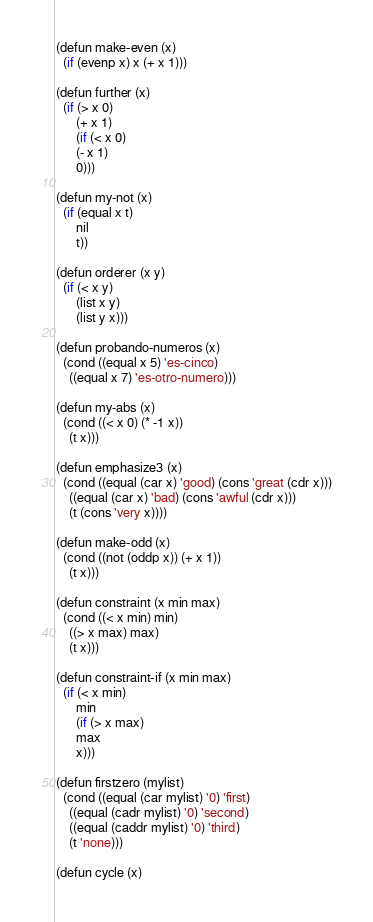Convert code to text. <code><loc_0><loc_0><loc_500><loc_500><_Lisp_>(defun make-even (x)
  (if (evenp x) x (+ x 1)))

(defun further (x)
  (if (> x 0)
      (+ x 1)
      (if (< x 0)
	  (- x 1)
	  0)))

(defun my-not (x)
  (if (equal x t)
      nil
      t))

(defun orderer (x y)
  (if (< x y)
      (list x y)
      (list y x)))

(defun probando-numeros (x)
  (cond ((equal x 5) 'es-cinco)
	((equal x 7) 'es-otro-numero)))

(defun my-abs (x)
  (cond ((< x 0) (* -1 x))
	(t x)))

(defun emphasize3 (x)
  (cond ((equal (car x) 'good) (cons 'great (cdr x)))
	((equal (car x) 'bad) (cons 'awful (cdr x)))
	(t (cons 'very x))))

(defun make-odd (x)
  (cond ((not (oddp x)) (+ x 1))
	(t x)))

(defun constraint (x min max)
  (cond ((< x min) min)
	((> x max) max)
	(t x)))

(defun constraint-if (x min max)
  (if (< x min)
      min
      (if (> x max)
	  max
	  x)))

(defun firstzero (mylist)
  (cond ((equal (car mylist) '0) 'first)
	((equal (cadr mylist) '0) 'second)
	((equal (caddr mylist) '0) 'third)
	(t 'none)))

(defun cycle (x)</code> 